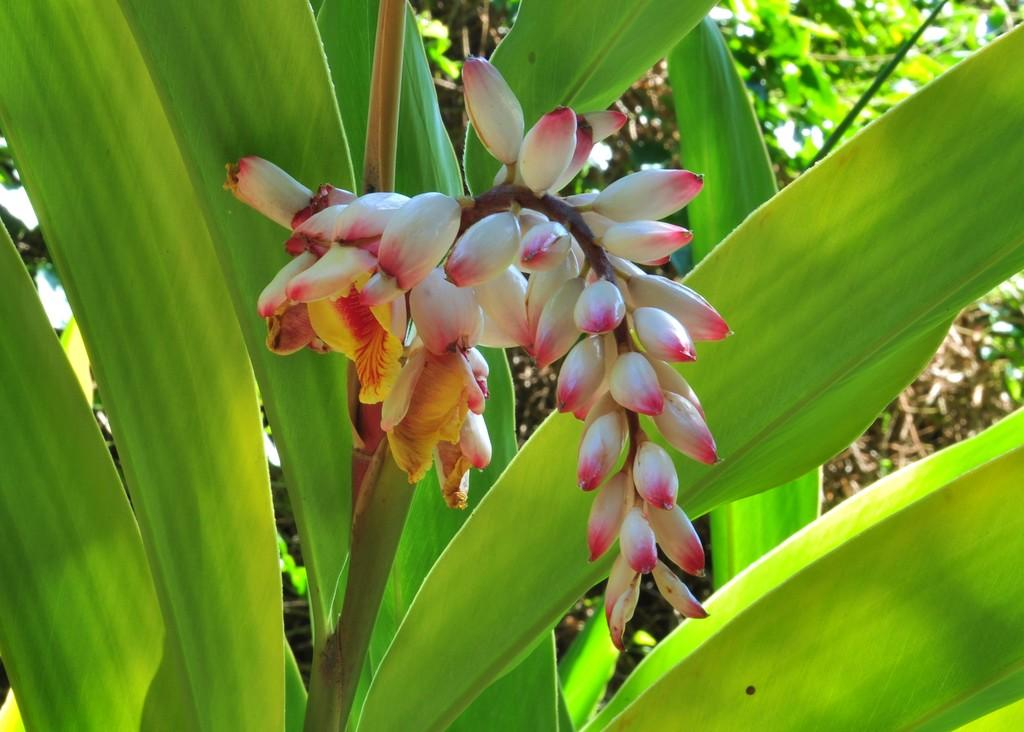What type of plant is present in the image? There is a plant with flowers in the image. What can be seen in the background of the image? There is grass visible in the background of the image. What is the chance of the grandfather sleeping in the bedroom in the image? There is no mention of a grandfather or a bedroom in the image, so it is impossible to determine the likelihood of the grandfather sleeping in the bedroom. 